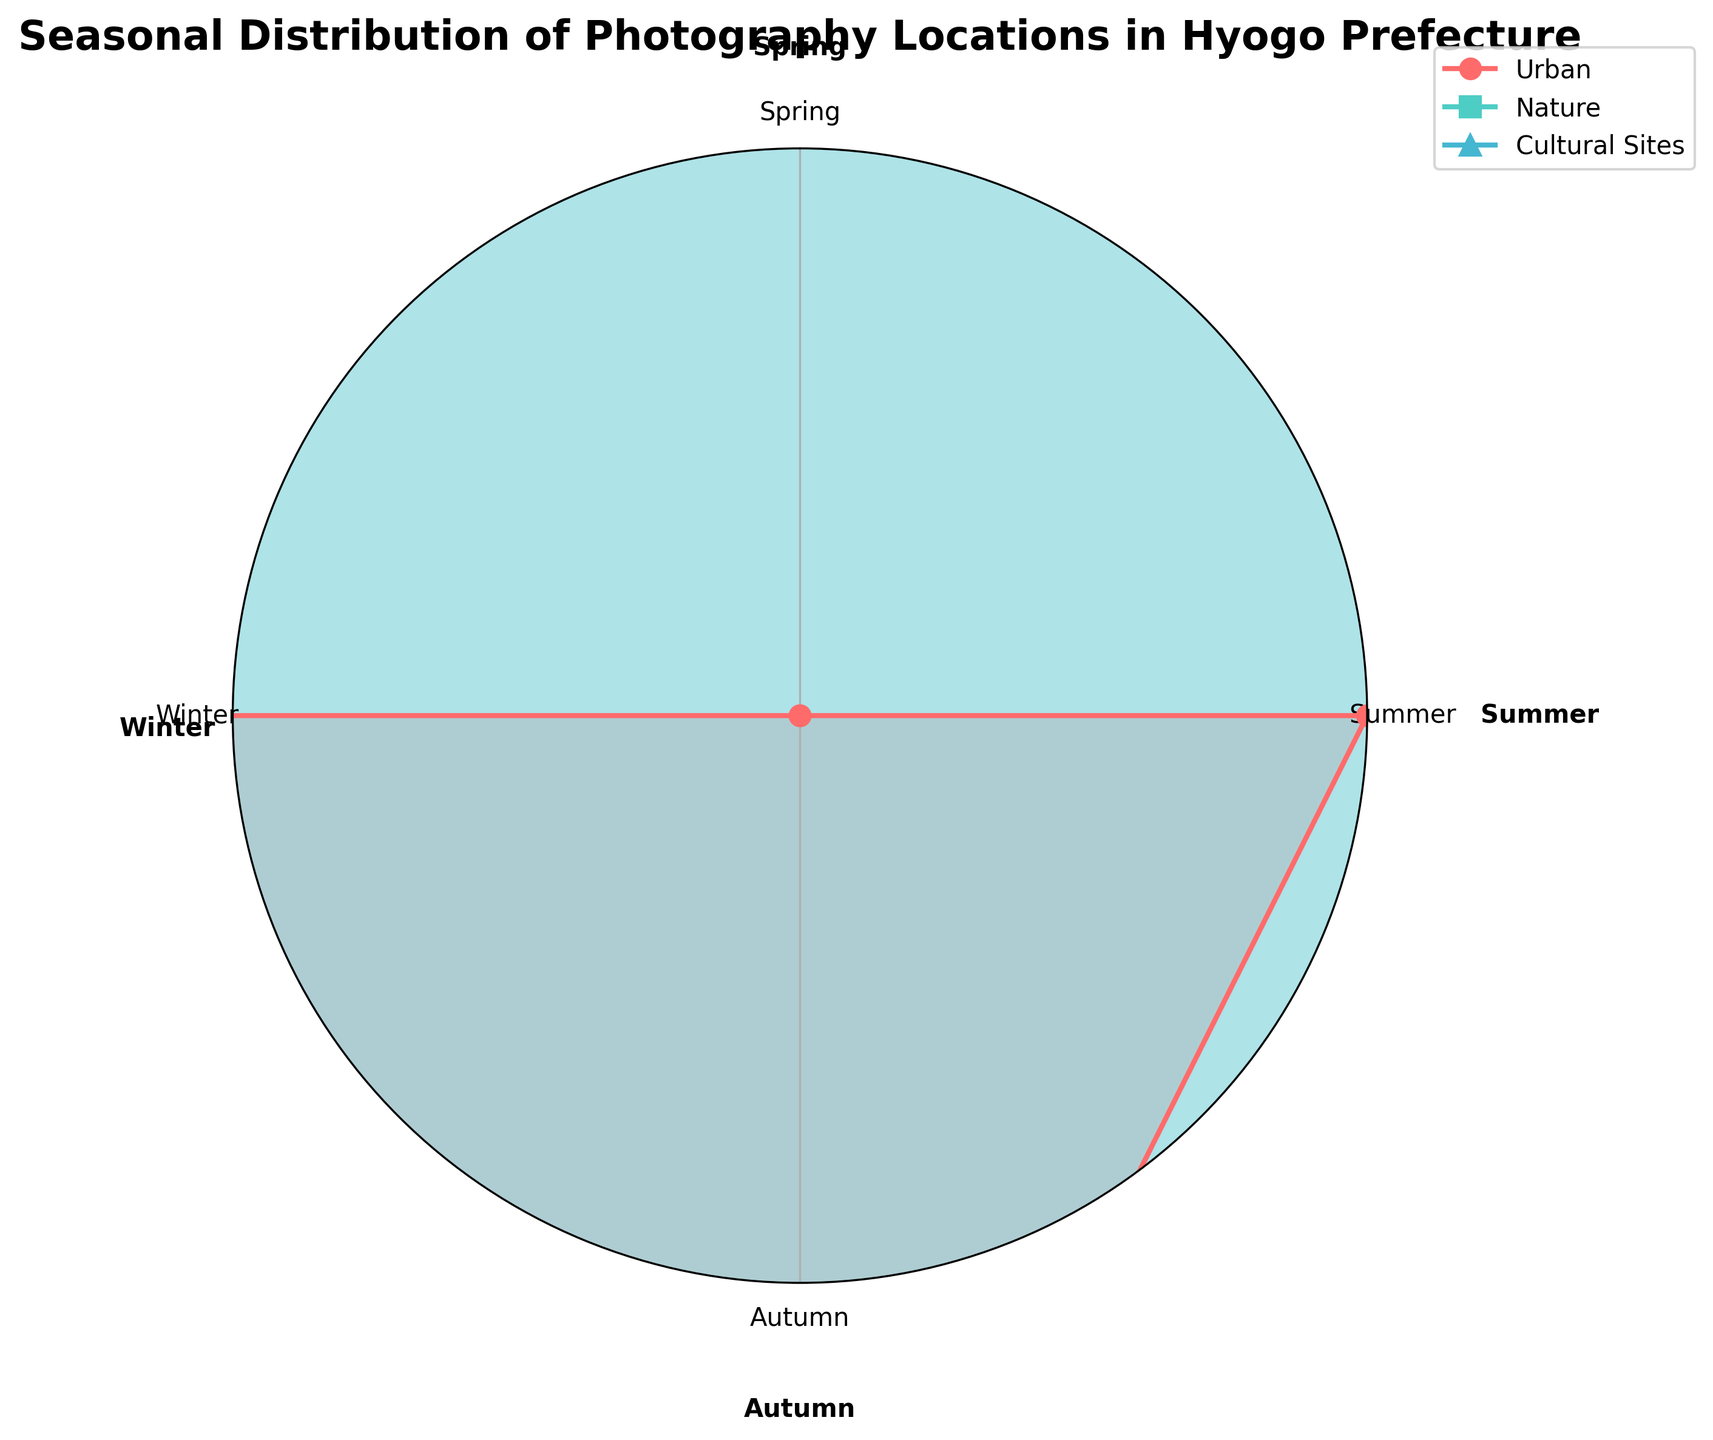What are the seasons shown in the plot? The seasons are labeled around the radar chart, indicating the different periods under consideration for photography locations. They include Spring, Summer, Autumn, and Winter.
Answer: Spring, Summer, Autumn, Winter Which category covers Mount Rokko? The radar chart shows the locations for each category in each season, where Mount Rokko is listed under the 'Nature' category. This is determined by looking at the Nature group and observing that Mount Rokko is identified for Spring.
Answer: Nature How many total locations are captured in the 'Cultural Sites' category? Each season has one location listed for 'Cultural Sites'. By counting these locations across Spring, Summer, Autumn, and Winter, we find there are four locations in total.
Answer: 4 Which category has a location in Nishinomiya Gardens during Autumn? The plot shows specific locations for each season within each category. For Autumn, Nishinomiya Gardens is listed under the 'Urban' category.
Answer: Urban What location is captured under the 'Nature' category for Winter? By examining the 'Nature' category and following it to the Winter segment, we observe that Mount Maya is the location recorded.
Answer: Mount Maya Compare the number of locations listed for 'Nature' and 'Urban' categories in the Summer. Are they equal? By checking the Summer segment for both categories, we spot that 'Nature' has Awaiji Island, and 'Urban' has Osaka Bay Area, providing one location each for Summer. This suggests the number of locations listed in Summer for both categories are the same.
Answer: Yes Is there a season where the 'Cultural Sites' category has Himeji Castle Gardens listed? We have to check each seasonal location under 'Cultural Sites'. Himeji Castle Gardens appears under 'Nature' for Autumn, and thus, it is not listed under 'Cultural Sites' for any season.
Answer: No Considering only the 'Urban' and 'Nature' categories, which has a location at Meriken Park during Winter? The 'Urban' category lists Meriken Park as its Winter location, while the 'Nature' category lists Mount Maya. Hence, 'Urban' has Meriken Park in Winter.
Answer: Urban Do 'Nature' and 'Cultural Sites' share any location during Spring? We should compare the locations listed in Spring for both categories. 'Nature' lists Mount Rokko, and 'Cultural Sites' lists Sorakuen Garden. Since the locations differ, there is no shared location in Spring.
Answer: No Which category has a location at Kofuku-ji Temple, and during which season? Observing the locations under 'Cultural Sites', Kofuku-ji Temple appears during Summer, indicating the 'Cultural Sites' category for that season.
Answer: Cultural Sites, Summer 